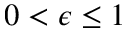<formula> <loc_0><loc_0><loc_500><loc_500>0 < \epsilon \leq 1</formula> 